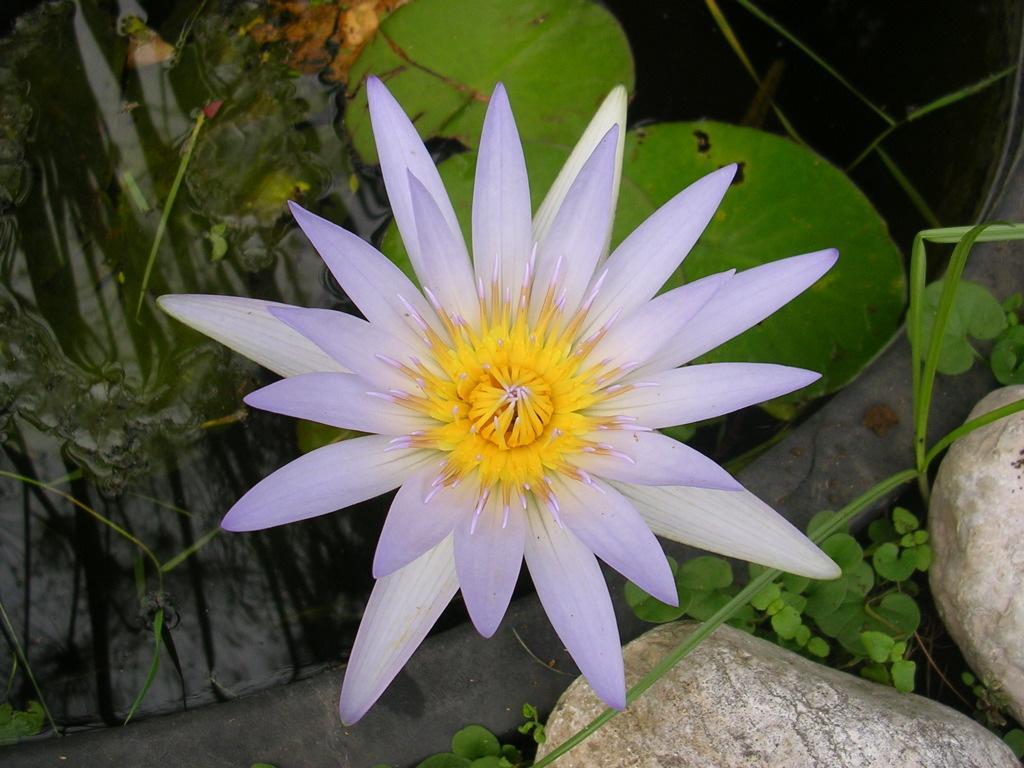Please provide a concise description of this image. In the image there is a yellow and purple flower, it has huge leaves and beside the flower there are two big stones. 